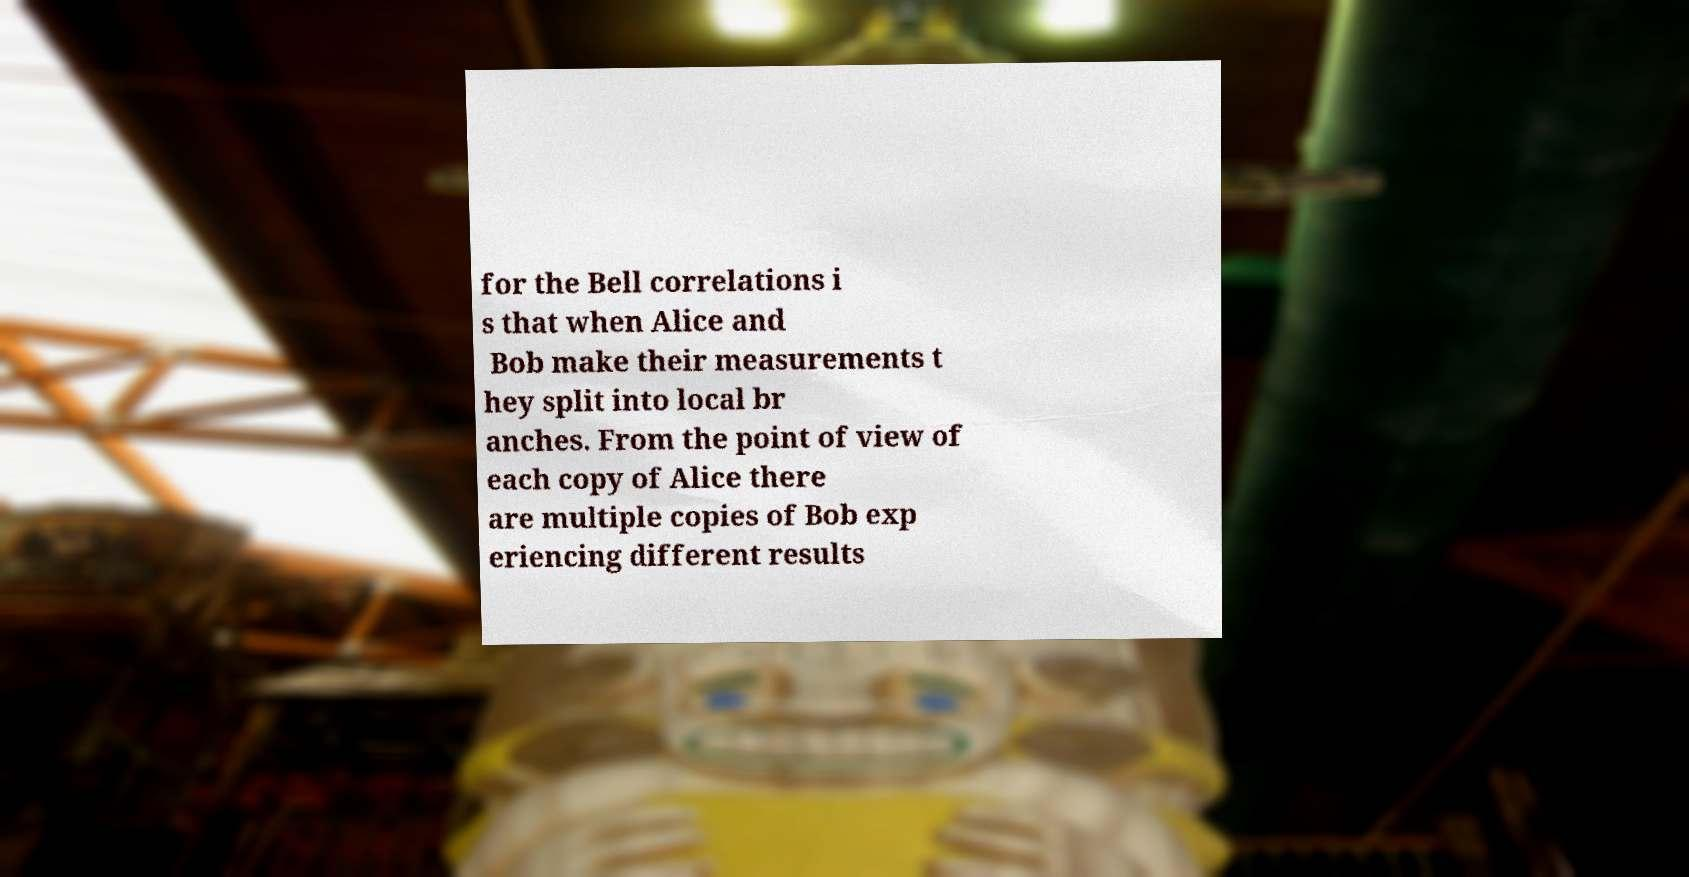What messages or text are displayed in this image? I need them in a readable, typed format. for the Bell correlations i s that when Alice and Bob make their measurements t hey split into local br anches. From the point of view of each copy of Alice there are multiple copies of Bob exp eriencing different results 